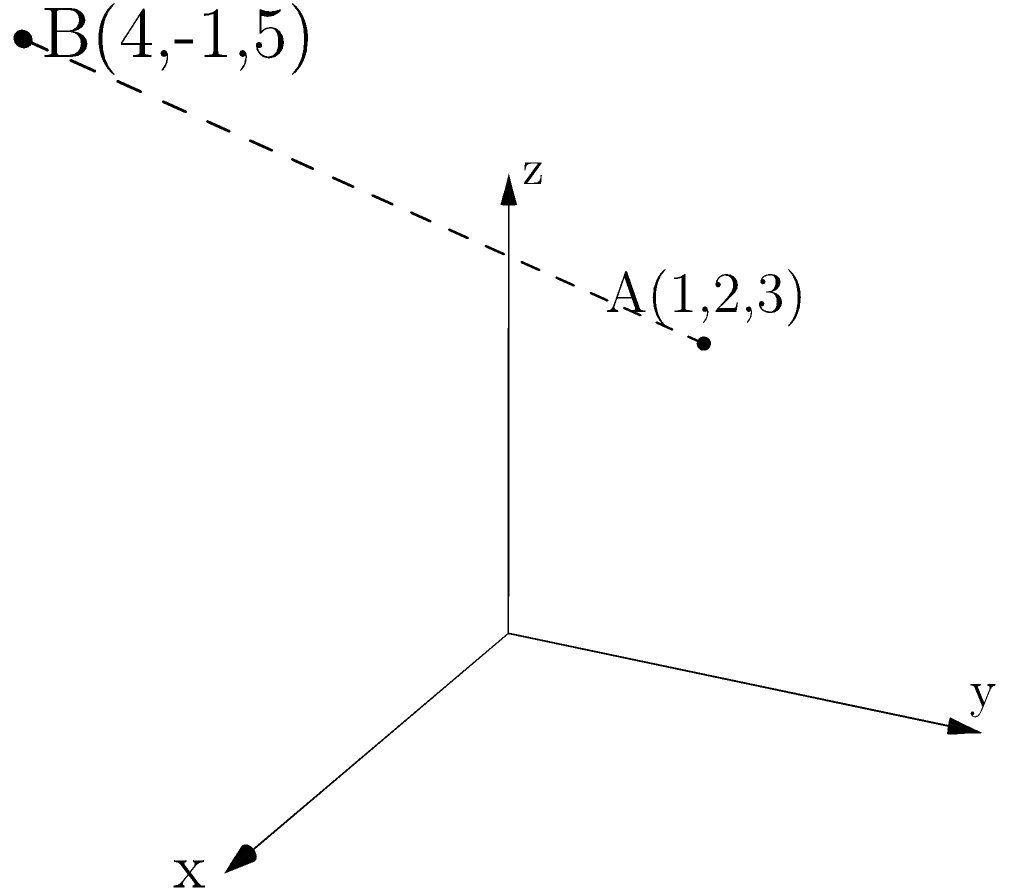In your drama class with Prof. Schvey, you're tasked with designing a 3D set. Two crucial points in your design are represented by A(1,2,3) and B(4,-1,5) in a 3D coordinate system. Calculate the distance between these two points to ensure proper spacing on stage. Let's approach this step-by-step:

1) The formula for distance between two points $(x_1, y_1, z_1)$ and $(x_2, y_2, z_2)$ in 3D space is:

   $$d = \sqrt{(x_2-x_1)^2 + (y_2-y_1)^2 + (z_2-z_1)^2}$$

2) In this case:
   Point A: $(x_1, y_1, z_1) = (1, 2, 3)$
   Point B: $(x_2, y_2, z_2) = (4, -1, 5)$

3) Let's substitute these into our formula:

   $$d = \sqrt{(4-1)^2 + (-1-2)^2 + (5-3)^2}$$

4) Simplify inside the parentheses:

   $$d = \sqrt{3^2 + (-3)^2 + 2^2}$$

5) Calculate the squares:

   $$d = \sqrt{9 + 9 + 4}$$

6) Add inside the square root:

   $$d = \sqrt{22}$$

7) This is our final answer, but we can simplify it further:

   $$d = \sqrt{22} = \sqrt{2} \cdot \sqrt{11}$$
Answer: $\sqrt{22}$ or $\sqrt{2} \cdot \sqrt{11}$ 